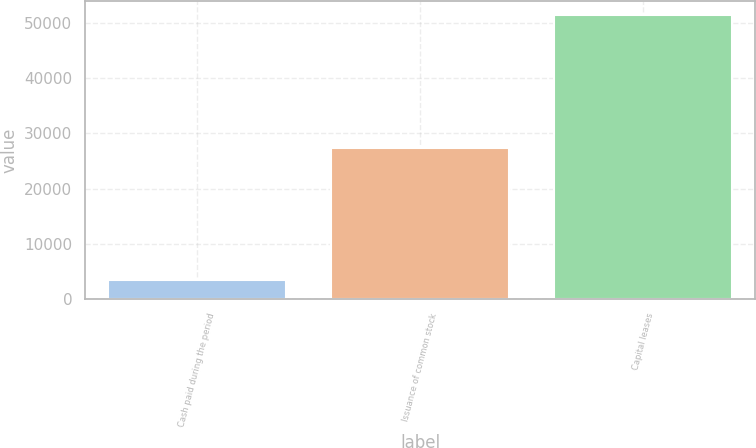Convert chart to OTSL. <chart><loc_0><loc_0><loc_500><loc_500><bar_chart><fcel>Cash paid during the period<fcel>Issuance of common stock<fcel>Capital leases<nl><fcel>3349<fcel>27399.7<fcel>51450.4<nl></chart> 